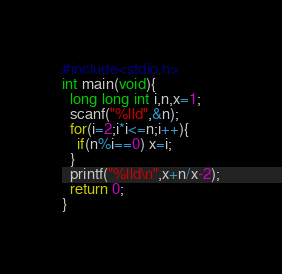Convert code to text. <code><loc_0><loc_0><loc_500><loc_500><_C_>#include<stdio.h>
int main(void){
  long long int i,n,x=1;
  scanf("%lld",&n);
  for(i=2;i*i<=n;i++){
    if(n%i==0) x=i;
  }
  printf("%lld\n",x+n/x-2);
  return 0;
}</code> 